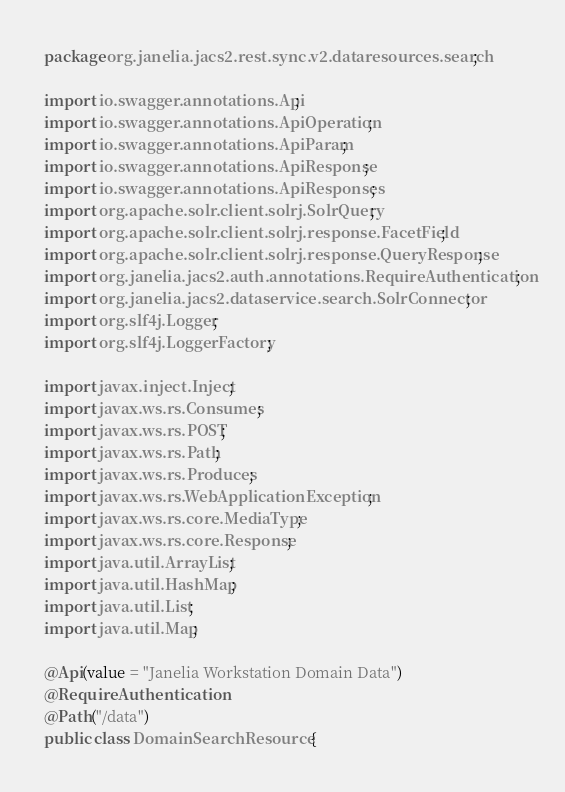Convert code to text. <code><loc_0><loc_0><loc_500><loc_500><_Java_>package org.janelia.jacs2.rest.sync.v2.dataresources.search;

import io.swagger.annotations.Api;
import io.swagger.annotations.ApiOperation;
import io.swagger.annotations.ApiParam;
import io.swagger.annotations.ApiResponse;
import io.swagger.annotations.ApiResponses;
import org.apache.solr.client.solrj.SolrQuery;
import org.apache.solr.client.solrj.response.FacetField;
import org.apache.solr.client.solrj.response.QueryResponse;
import org.janelia.jacs2.auth.annotations.RequireAuthentication;
import org.janelia.jacs2.dataservice.search.SolrConnector;
import org.slf4j.Logger;
import org.slf4j.LoggerFactory;

import javax.inject.Inject;
import javax.ws.rs.Consumes;
import javax.ws.rs.POST;
import javax.ws.rs.Path;
import javax.ws.rs.Produces;
import javax.ws.rs.WebApplicationException;
import javax.ws.rs.core.MediaType;
import javax.ws.rs.core.Response;
import java.util.ArrayList;
import java.util.HashMap;
import java.util.List;
import java.util.Map;

@Api(value = "Janelia Workstation Domain Data")
@RequireAuthentication
@Path("/data")
public class DomainSearchResource {</code> 